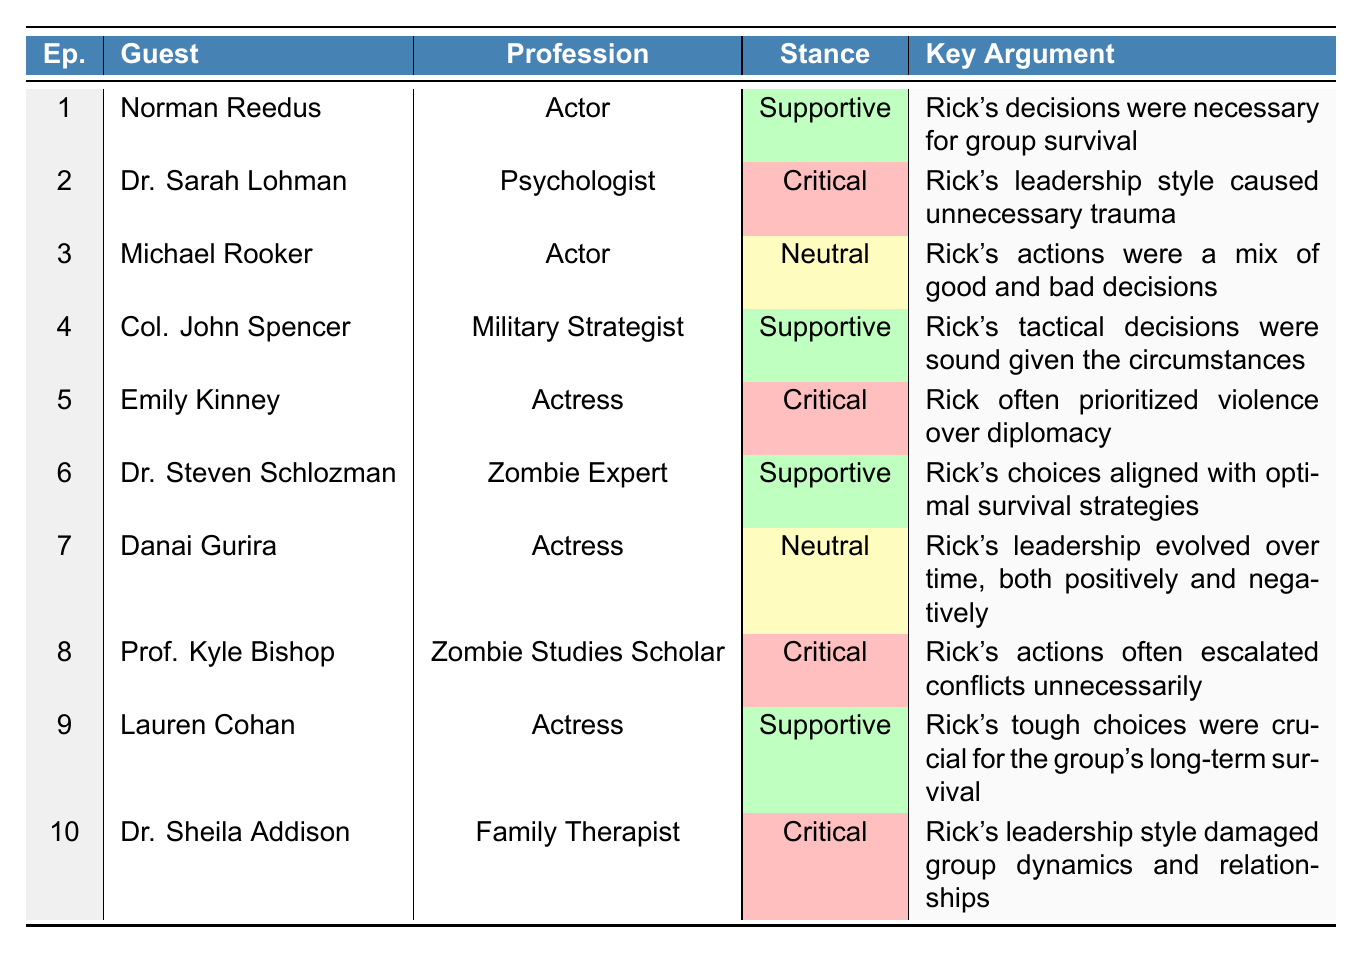What was the stance of Danai Gurira on Rick's actions? In the table, Danai Gurira's stance is listed as "Neutral."
Answer: Neutral How many guests had a supportive stance towards Rick's actions? By counting the rows with "Supportive" in the stance column (Norman Reedus, Col. John Spencer, Dr. Steven Schlozman, and Lauren Cohan), there are 4 supportive guests.
Answer: 4 What key argument did Dr. Sheila Addison present? Dr. Sheila Addison's key argument stated that "Rick's leadership style damaged group dynamics and relationships."
Answer: Damaged group dynamics Is it true that all guest actors were supportive of Rick's decisions? No, not all guest actors were supportive. Emily Kinney, who is also an actress, provided a critical stance on Rick's actions.
Answer: False Which profession had the most critical stances? The professions listed with a critical stance include "Psychologist," "Actress," "Zombie Studies Scholar," and "Family Therapist." There are more critical stances from these categories than any others.
Answer: Psychology and Acting Can you identify a guest whose argument was that Rick's actions escalated conflicts? Prof. Kyle Bishop's key argument was that "Rick's actions often escalated conflicts unnecessarily."
Answer: Prof. Kyle Bishop Which episode featured the guest who believed Rick's choices aligned with survival strategies? Episode 6 featured Dr. Steven Schlozman, who argued that Rick's choices aligned with optimal survival strategies.
Answer: Episode 6 What is the difference between the number of supportive and critical stances? There are 4 supportive stances and 6 critical stances, so the difference is 6 - 4 = 2.
Answer: 2 Which guest was the only one to hold a neutral stance and what was their profession? Michael Rooker was the only guest to hold a neutral stance, and his profession is "Actor."
Answer: Actor Summarize the overall sentiment of the guests towards Rick's actions. There are 4 supportive, 6 critical, and 2 neutral stances overall, indicating a more critical sentiment towards Rick's actions among the guests.
Answer: Critical sentiment 